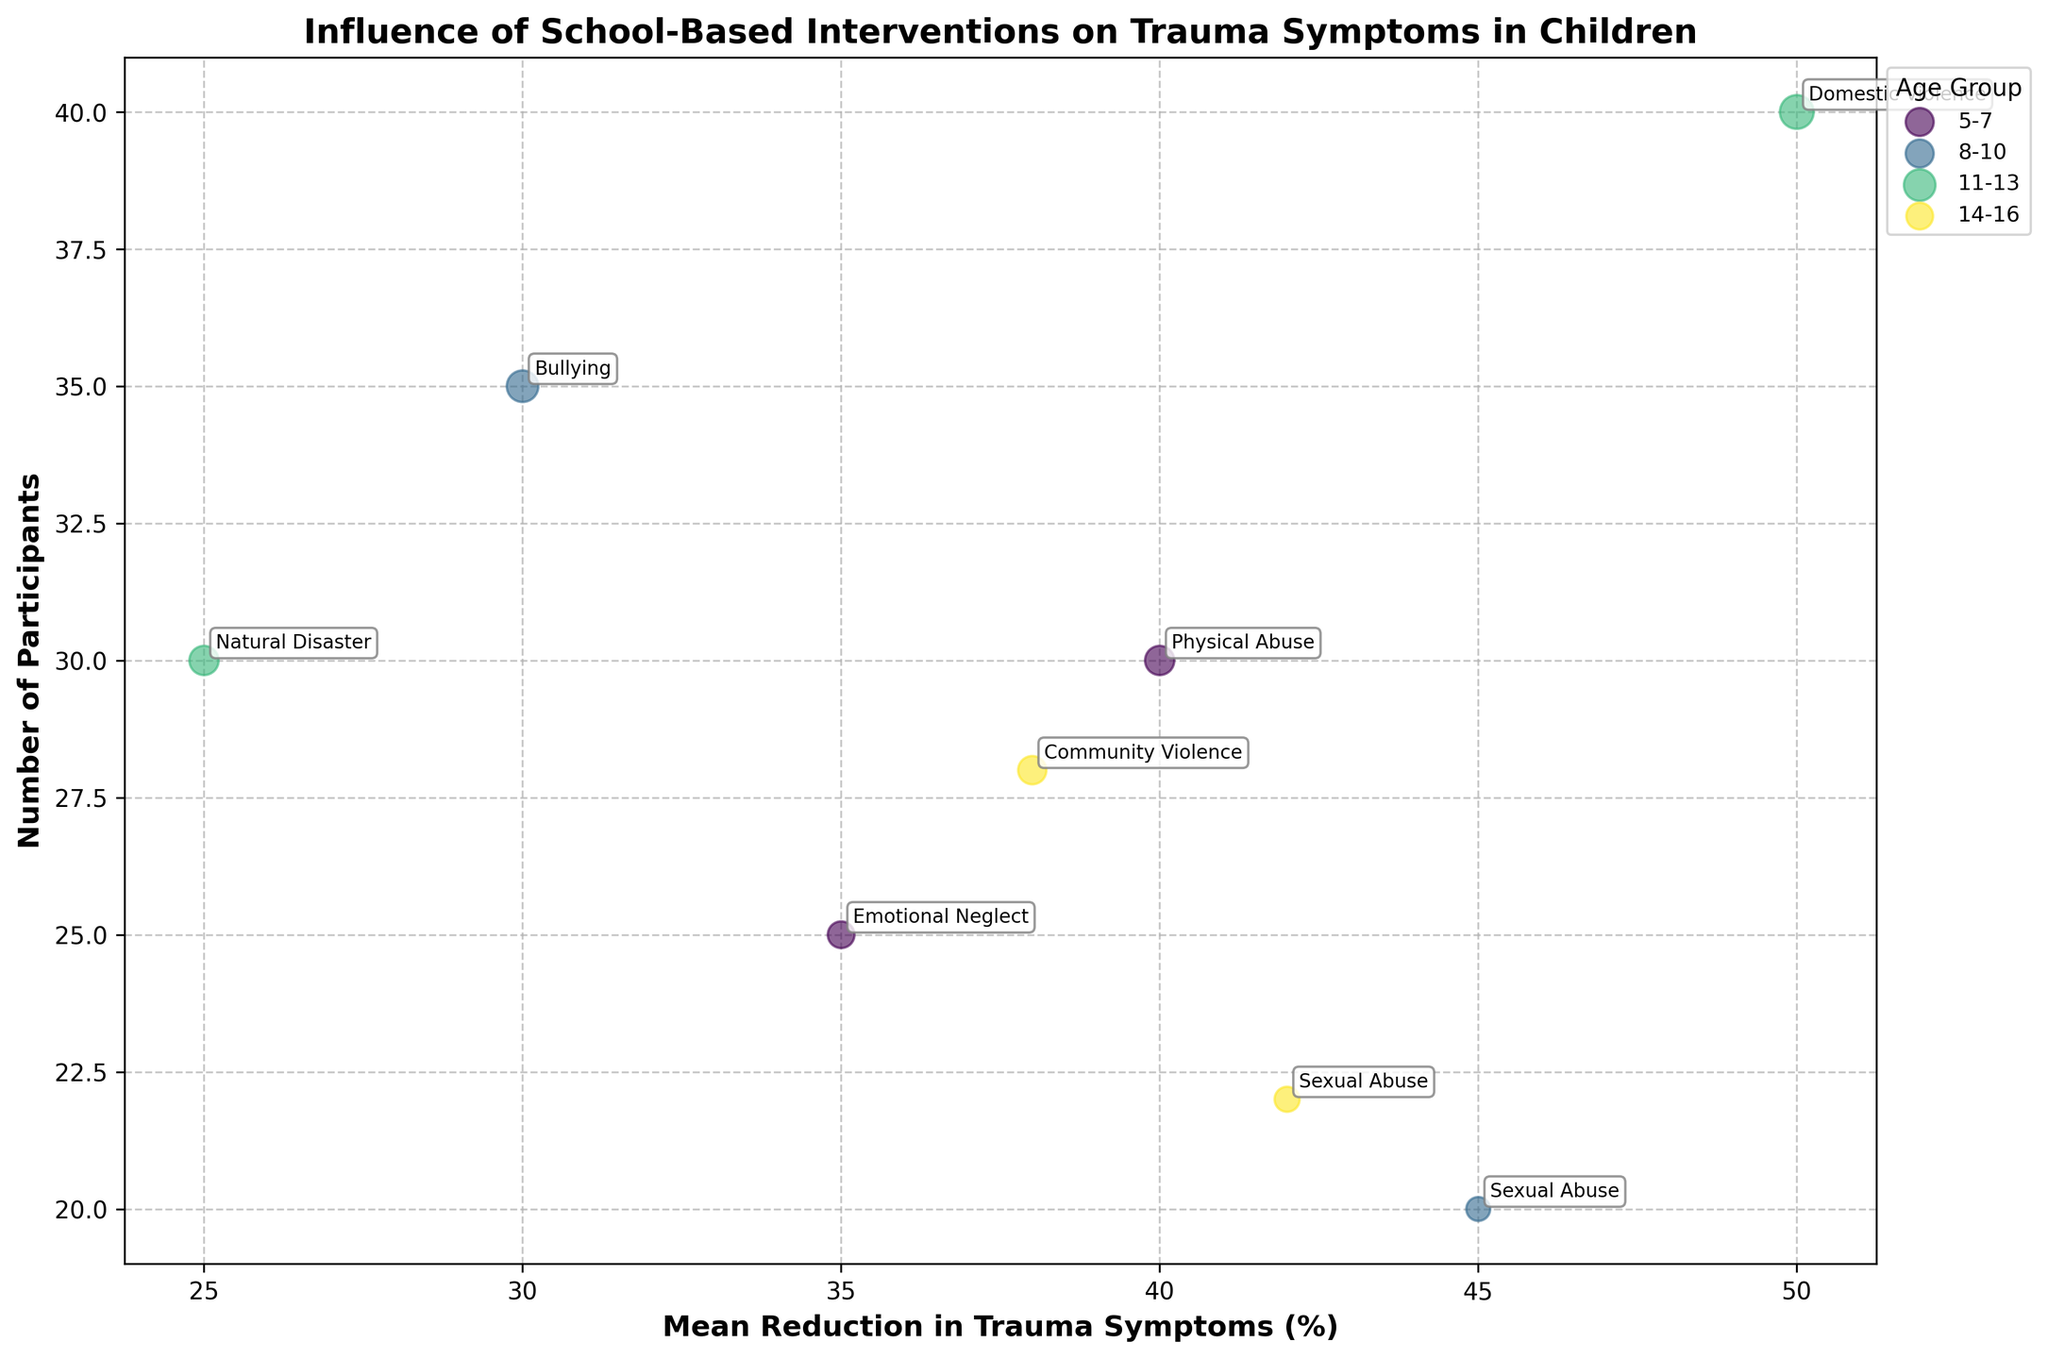What is the overall title of the figure? The title can be found at the top of the figure. It is: "Influence of School-Based Interventions on Trauma Symptoms in Children".
Answer: Influence of School-Based Interventions on Trauma Symptoms in Children How is the x-axis labeled? The x-axis label can be found along the horizontal axis at the bottom of the figure. It is: "Mean Reduction in Trauma Symptoms (%)".
Answer: Mean Reduction in Trauma Symptoms (%) How many participants were there in the 11-13 age group? Look for the bubbles associated with the 11-13 age group and count the number of participants, i.e., Number of Participants for each trauma in this age group.
Answer: 70 Which intervention led to the highest mean reduction in trauma symptoms for any age group? Identify the bubble with the highest x-axis value, which represents the maximum mean reduction in trauma symptoms. The corresponding label will indicate the intervention.
Answer: Mindfulness Training Compare the number of participants in Play Therapy and Group Discussion. Which had more participants? Find the bubbles labeled "Play Therapy" and "Group Discussion", then compare their y-axis values. Group Discussion had more participants.
Answer: Group Discussion What school had the highest mean reduction in trauma symptoms? Identify the bubble representing the highest x-axis value and see which school it corresponds to via the label linked with that bubble.
Answer: Carter Preparatory What is the sum of the mean reduction in trauma symptoms for the 8-10 age group? Add the mean reduction in trauma symptoms for "Cognitive Behavioral Therapy" (45) and "Group Discussion" (30) in the 8-10 age group: 45 + 30.
Answer: 75 Which type of trauma had the least reduction in symptoms in the 14-16 age group? Identify bubbles in the 14-16 age group, then find the one with the lowest x-axis value, representing the least percent reduction in trauma symptoms.
Answer: Community Violence Did any intervention produce a mean reduction of trauma symptoms above 50%? Examine the x-axis values of all bubbles to see if any exceed 50%. None of the interventions produced a reduction above 50%.
Answer: No In which age group is the intervention individual counseling used? Check the annotations near the bubbles labeled "Individual Counseling" to determine which age groups they belong to.
Answer: 14-16 